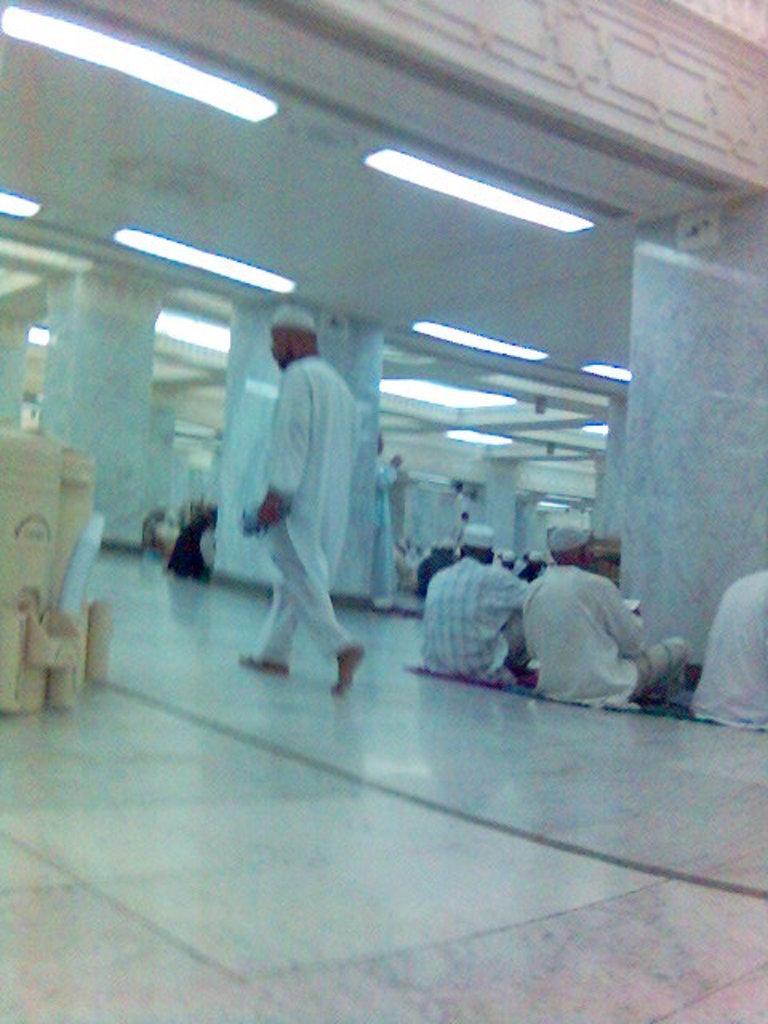Please provide a concise description of this image. In this picture there is a man who is wearing a cap and white dress. He is walking on the granite floor, beside him we can see another persons who are sitting on the carpet and holding book. In the background we can see many people sitting near to the pillars and wall. On the top we can see lights. On the left we can see water bottles. 